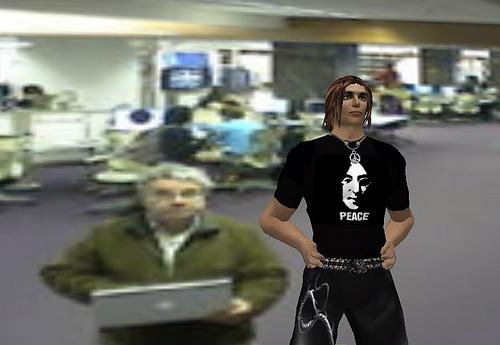Who is on the man's shirt?
Keep it brief. John lennon. Can you see a photoshopped item?
Concise answer only. Yes. What color is the man's jacket who is holding the computer?
Be succinct. Green. What type of stain is on his pants?
Be succinct. None. 